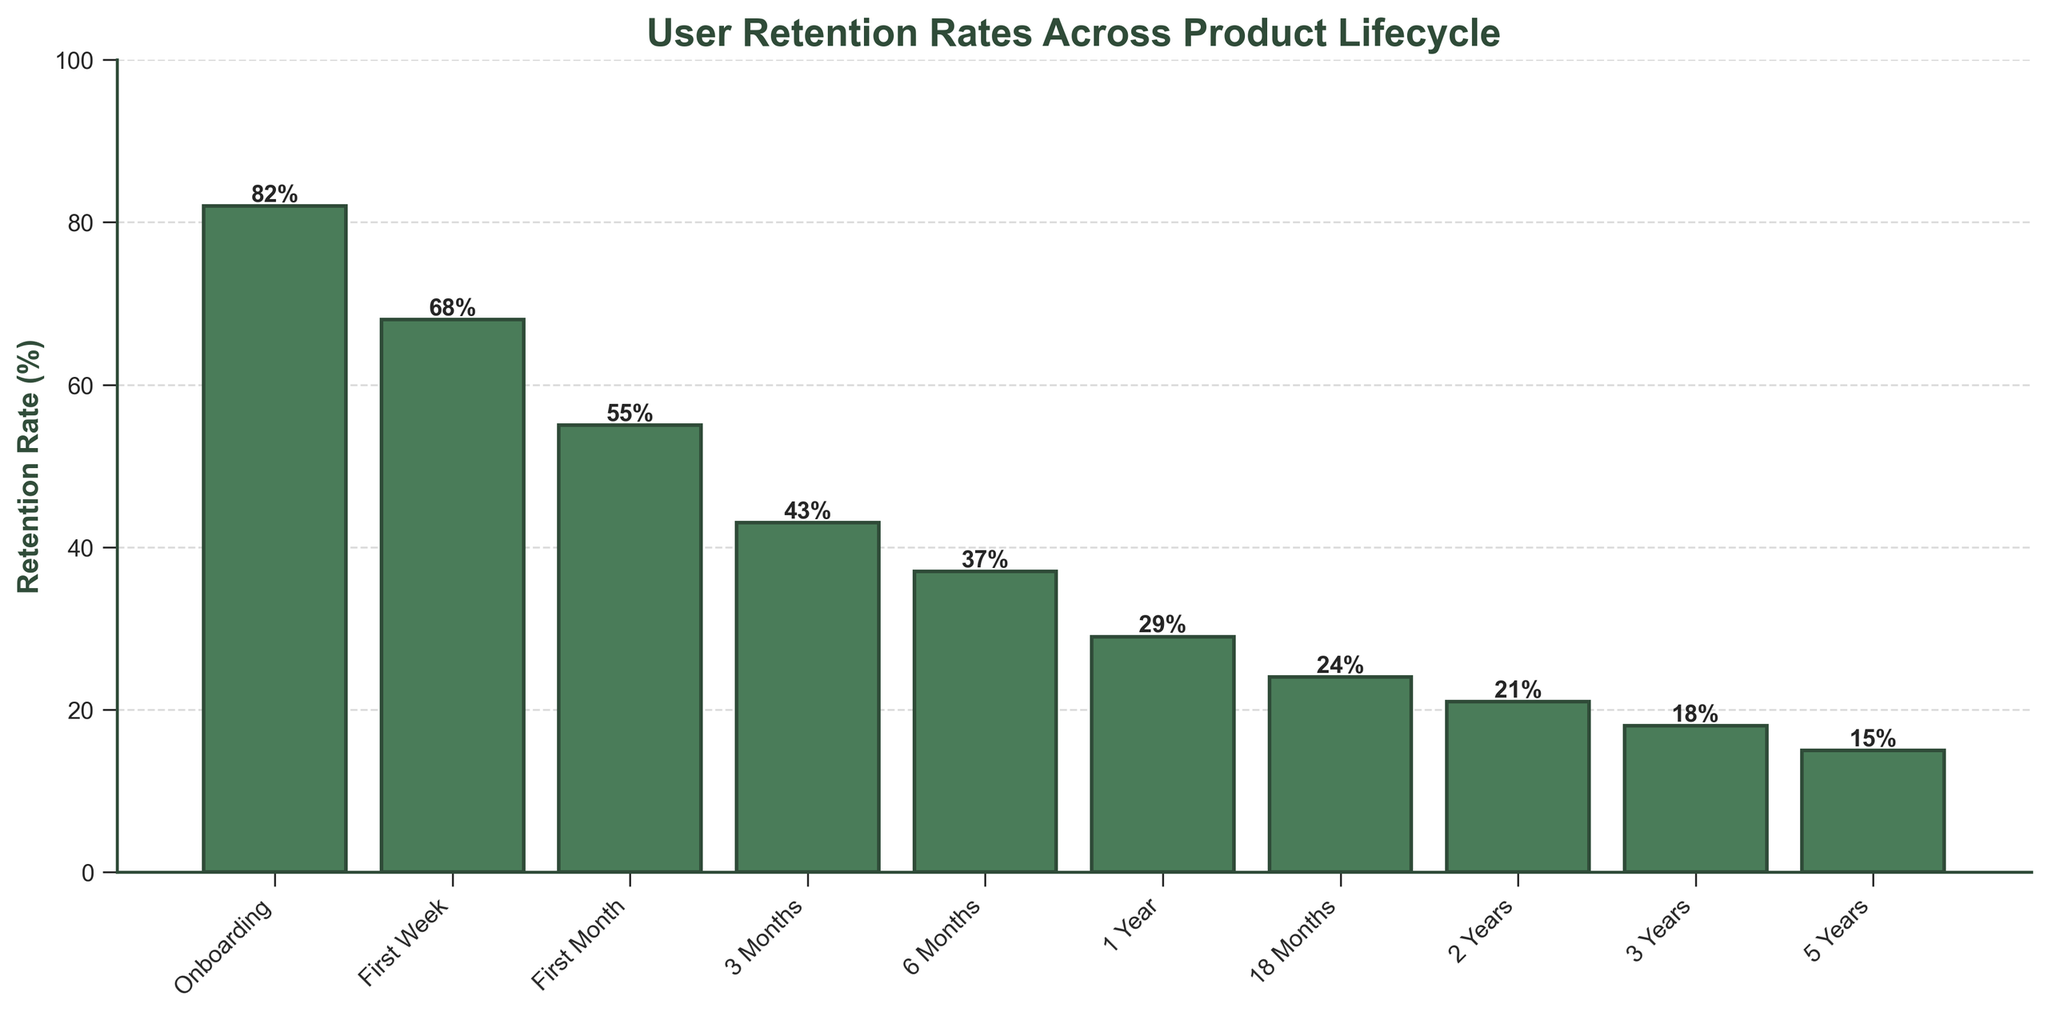What is the retention rate after the first week? The retention rate after the first week can be directly read from the figure where the bar is labeled "First Week," which shows the retention rate.
Answer: 68% Which stage shows the most significant drop in retention rate? To determine the stage with the most significant drop, compare the differences in retention rates between consecutive stages. The largest decrement occurs between the "Onboarding" and "First Week" stages.
Answer: From Onboarding to First Week What is the average retention rate over the first three stages? To find the average retention rate over the first three stages (Onboarding, First Week, and First Month), add their retention rates and divide by 3: (82 + 68 + 55) / 3 = 68.33.
Answer: 68.33% Is the retention rate at the 6-month stage higher or lower than the retention rate at the 1-year stage? Compare the retention rates at 6 months (37%) and 1 year (29%) by reading the heights of the respective bars in the figure.
Answer: Higher By how much does the retention rate decrease from the 1-year stage to the 18-month stage? Subtract the retention rate at 18 months from the retention rate at 1 year: 29% - 24% = 5%.
Answer: 5% What are the retention rates for the stages that occur more than 1 year after onboarding? Read the retention rates for stages that occur more than 1 year after onboarding: 1 Year (29%), 18 Months (24%), 2 Years (21%), 3 Years (18%), 5 Years (15%).
Answer: 29%, 24%, 21%, 18%, 15% How does the visual contrast of the bars assist in understanding the retention rates? The light green color of the bars makes it easy to differentiate between the different stages, and the dark border highlights the exact height, making it straightforward to read the retention rates annotated above each bar.
Answer: Clear visual distinction Which stage demonstrates the smallest drop in retention rate compared to its preceding stage? To identify the smallest drop, calculate the differences between consecutive stages. The smallest difference is between "3 Years" and "5 Years" (3%).
Answer: From 3 Years to 5 Years What is the total retention rate from Onboarding to 6 Months? To find the total retention rate, sum the values from "Onboarding" to "6 Months": 82 + 68 + 55 + 43 + 37 = 285.
Answer: 285% What percentage of users are retained after 3 years compared to the initial onboarding? Calculate the retention percentage after 3 years relative to the onboarding stage by dividing the 3-year retention rate by the onboarding rate and multiplying by 100: (18 / 82) * 100 ≈ 21.95%.
Answer: 21.95% 